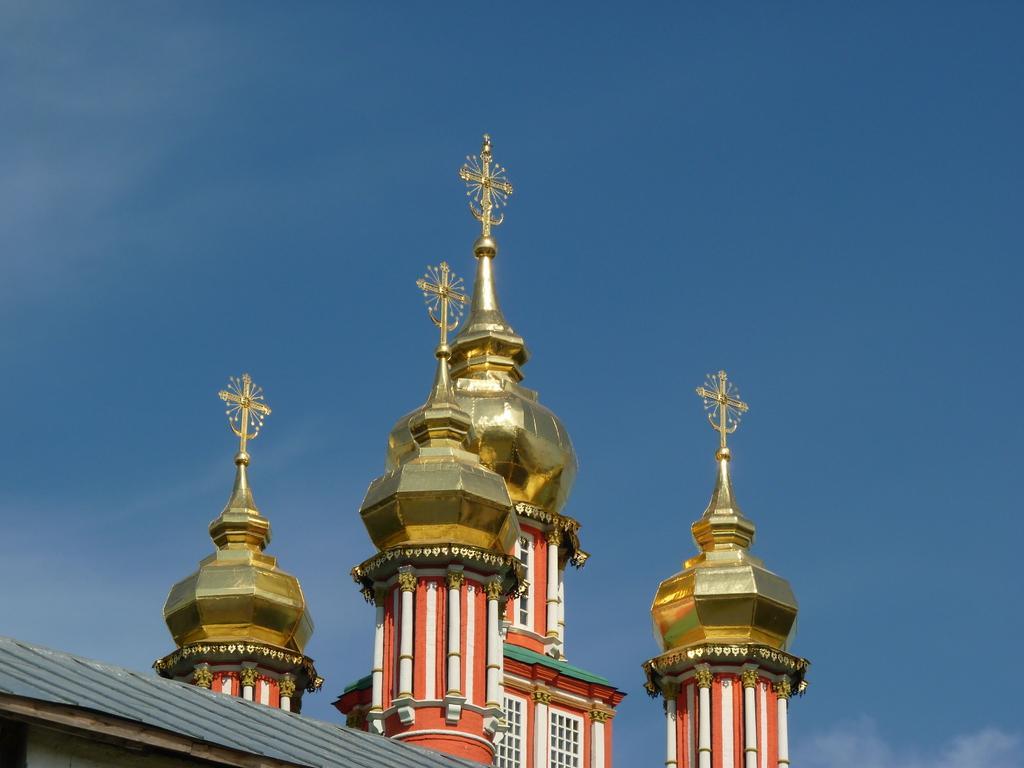In one or two sentences, can you explain what this image depicts? In this picture I can see there is a church and it has towers, there are four of them and it has a golden color polish on it. There are windows and the sky is clear. 